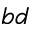Convert formula to latex. <formula><loc_0><loc_0><loc_500><loc_500>_ { b d }</formula> 